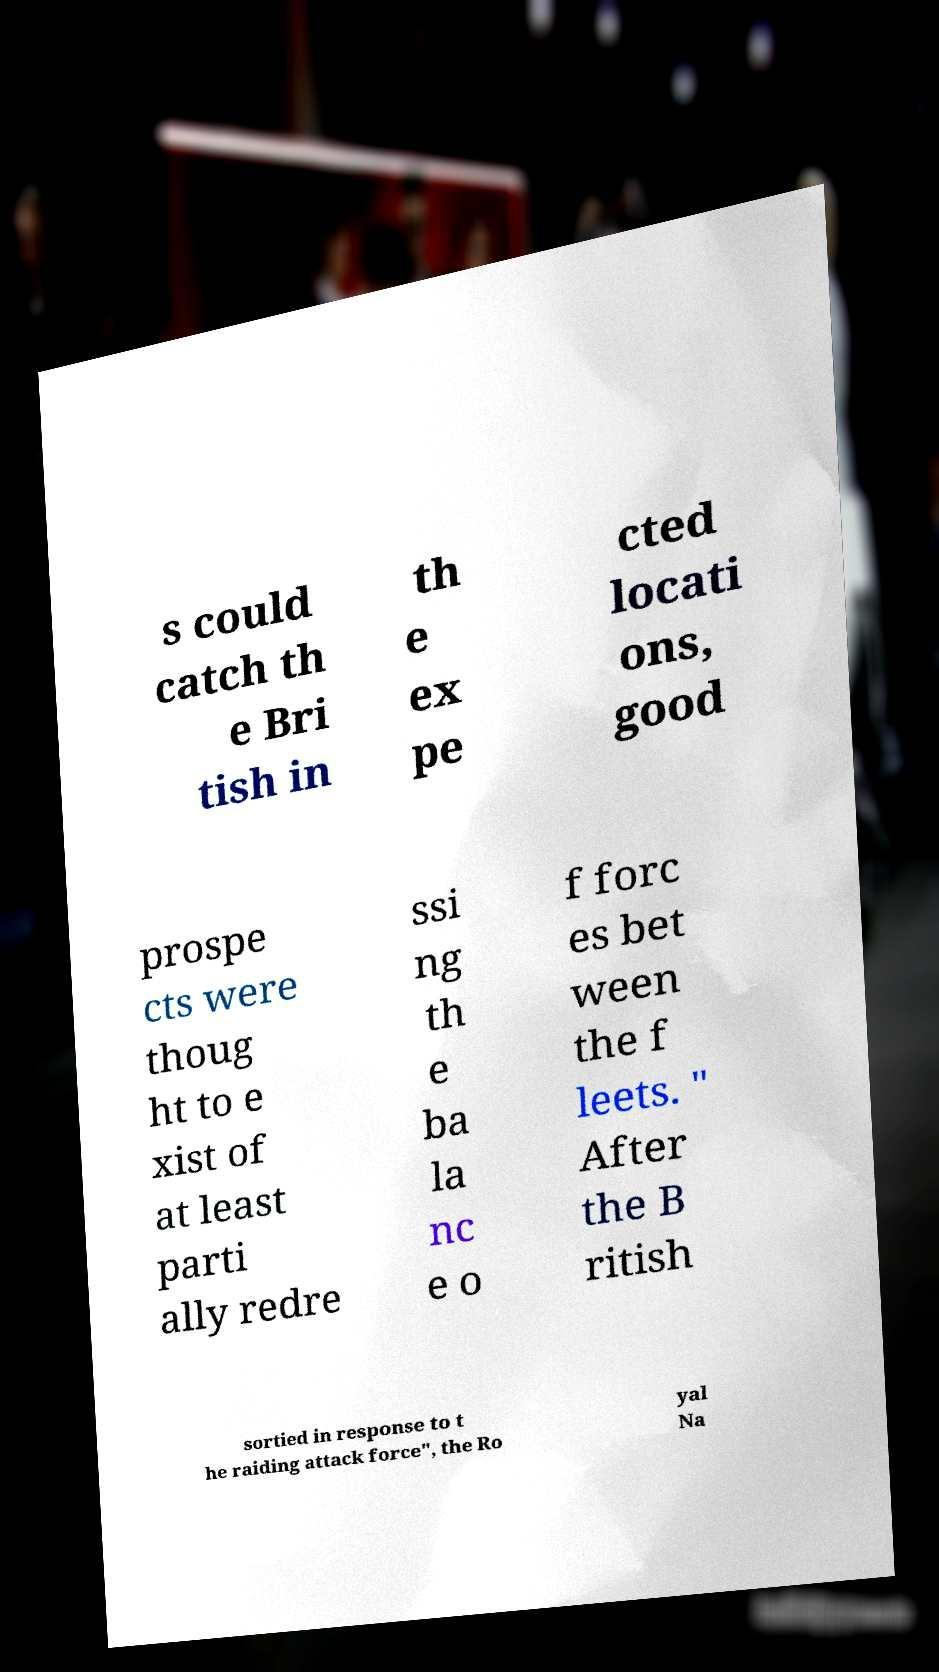Please identify and transcribe the text found in this image. s could catch th e Bri tish in th e ex pe cted locati ons, good prospe cts were thoug ht to e xist of at least parti ally redre ssi ng th e ba la nc e o f forc es bet ween the f leets. " After the B ritish sortied in response to t he raiding attack force", the Ro yal Na 